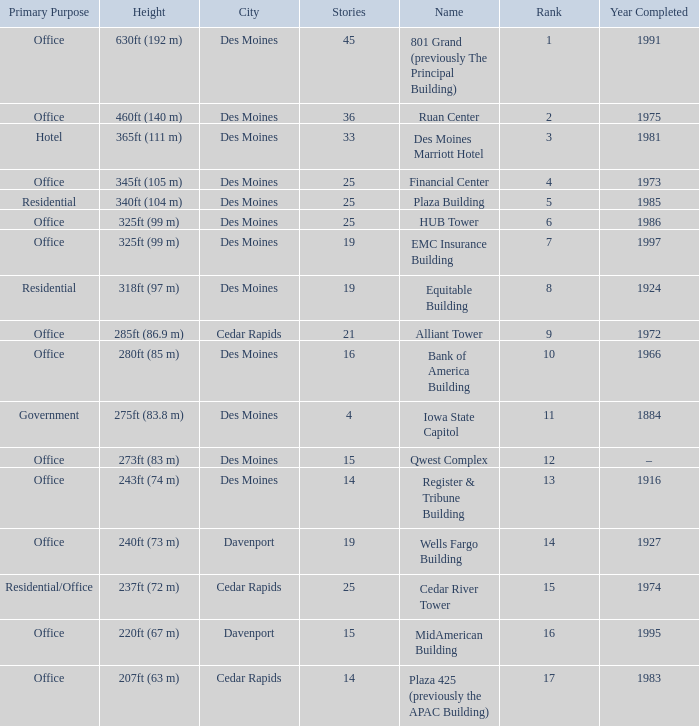What is the height of the EMC Insurance Building in Des Moines? 325ft (99 m). 